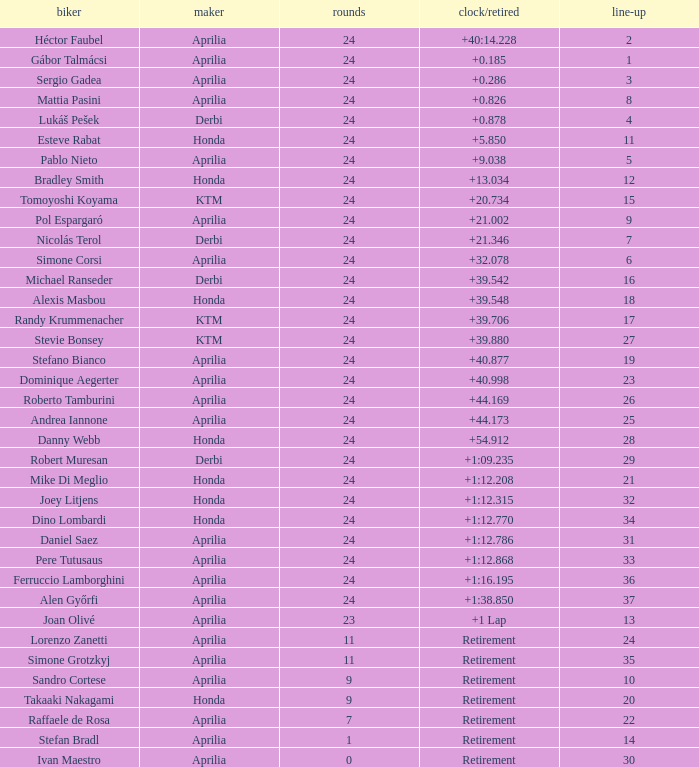Who manufactured the motorcycle that did 24 laps and 9 grids? Aprilia. 